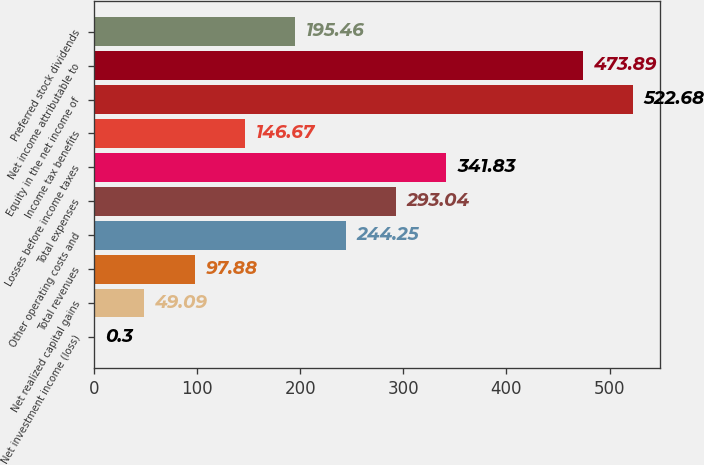Convert chart to OTSL. <chart><loc_0><loc_0><loc_500><loc_500><bar_chart><fcel>Net investment income (loss)<fcel>Net realized capital gains<fcel>Total revenues<fcel>Other operating costs and<fcel>Total expenses<fcel>Losses before income taxes<fcel>Income tax benefits<fcel>Equity in the net income of<fcel>Net income attributable to<fcel>Preferred stock dividends<nl><fcel>0.3<fcel>49.09<fcel>97.88<fcel>244.25<fcel>293.04<fcel>341.83<fcel>146.67<fcel>522.68<fcel>473.89<fcel>195.46<nl></chart> 